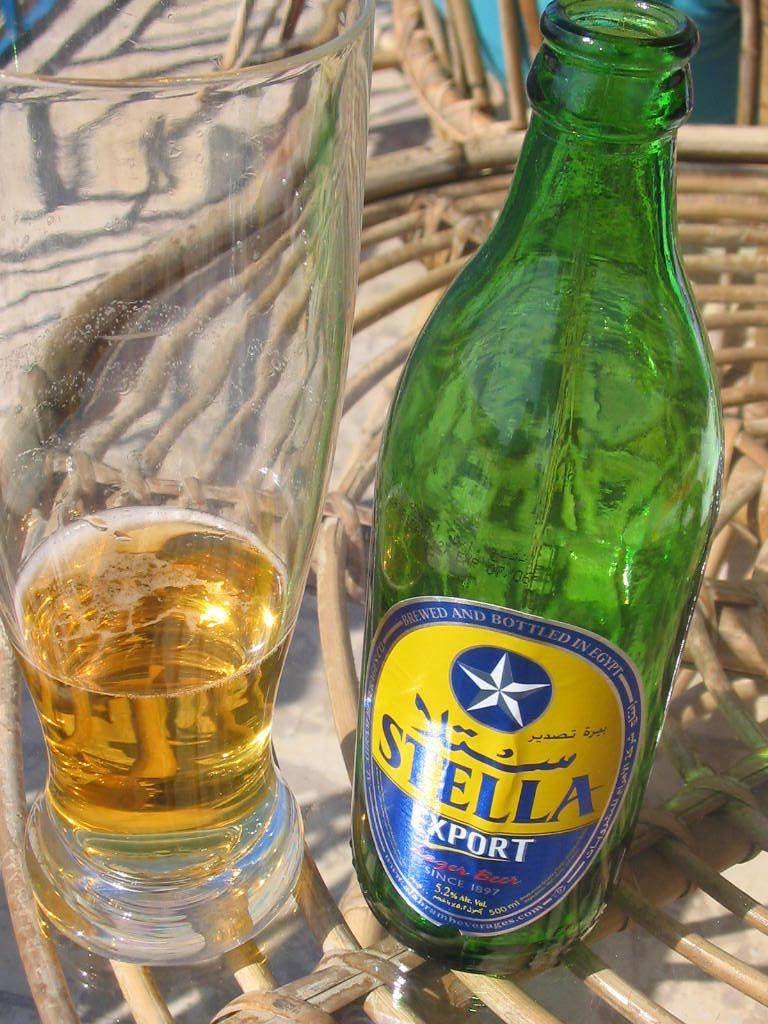What is located at the bottom of the image? There is a table at the bottom of the image. What objects are on the table? There is a bottle and a glass on the table. What is in the glass? The glass is filled with wine. Can you describe the chair in the image? There is a chair in the background of the image. What type of lamp is being used by the farmer in the image? There is no farmer or lamp present in the image. How does the skate interact with the wine in the glass? There is no skate present in the image, and therefore it cannot interact with the wine in the glass. 